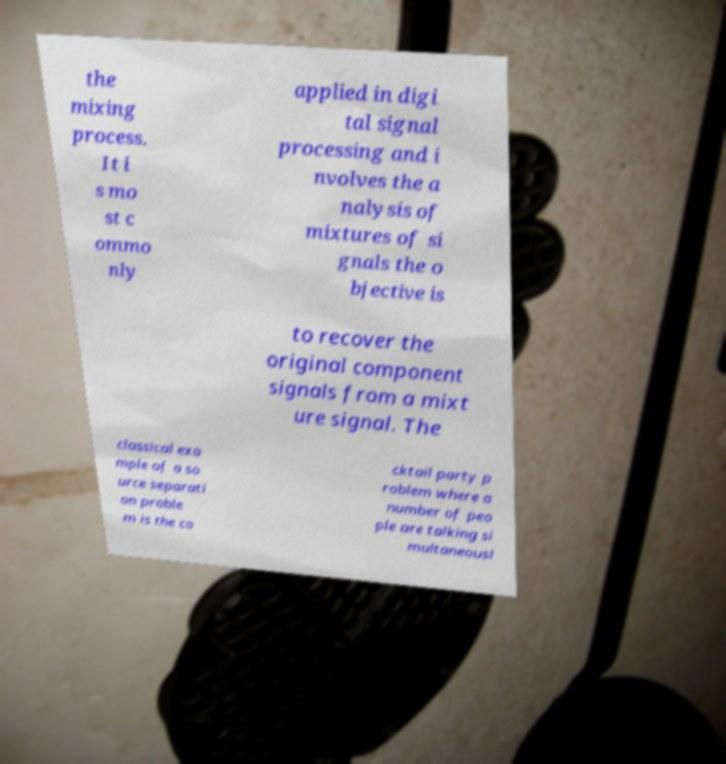Can you read and provide the text displayed in the image?This photo seems to have some interesting text. Can you extract and type it out for me? the mixing process. It i s mo st c ommo nly applied in digi tal signal processing and i nvolves the a nalysis of mixtures of si gnals the o bjective is to recover the original component signals from a mixt ure signal. The classical exa mple of a so urce separati on proble m is the co cktail party p roblem where a number of peo ple are talking si multaneousl 